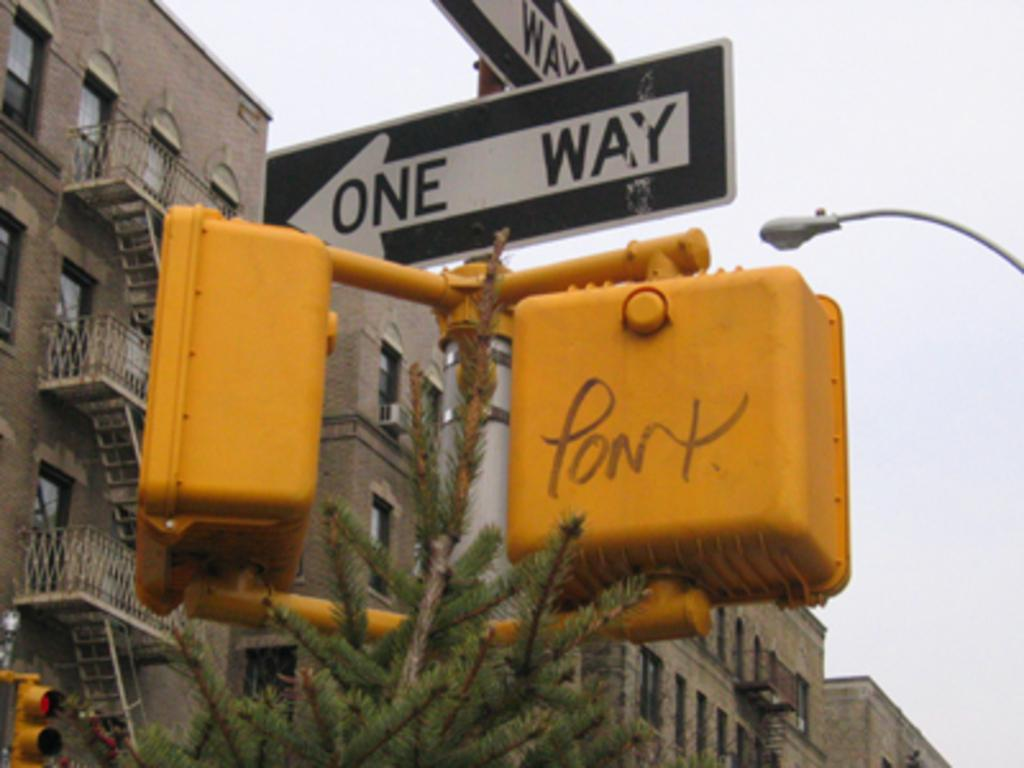Provide a one-sentence caption for the provided image. The walk signal has some graffiti on it and then 2 one-way signs above it. 